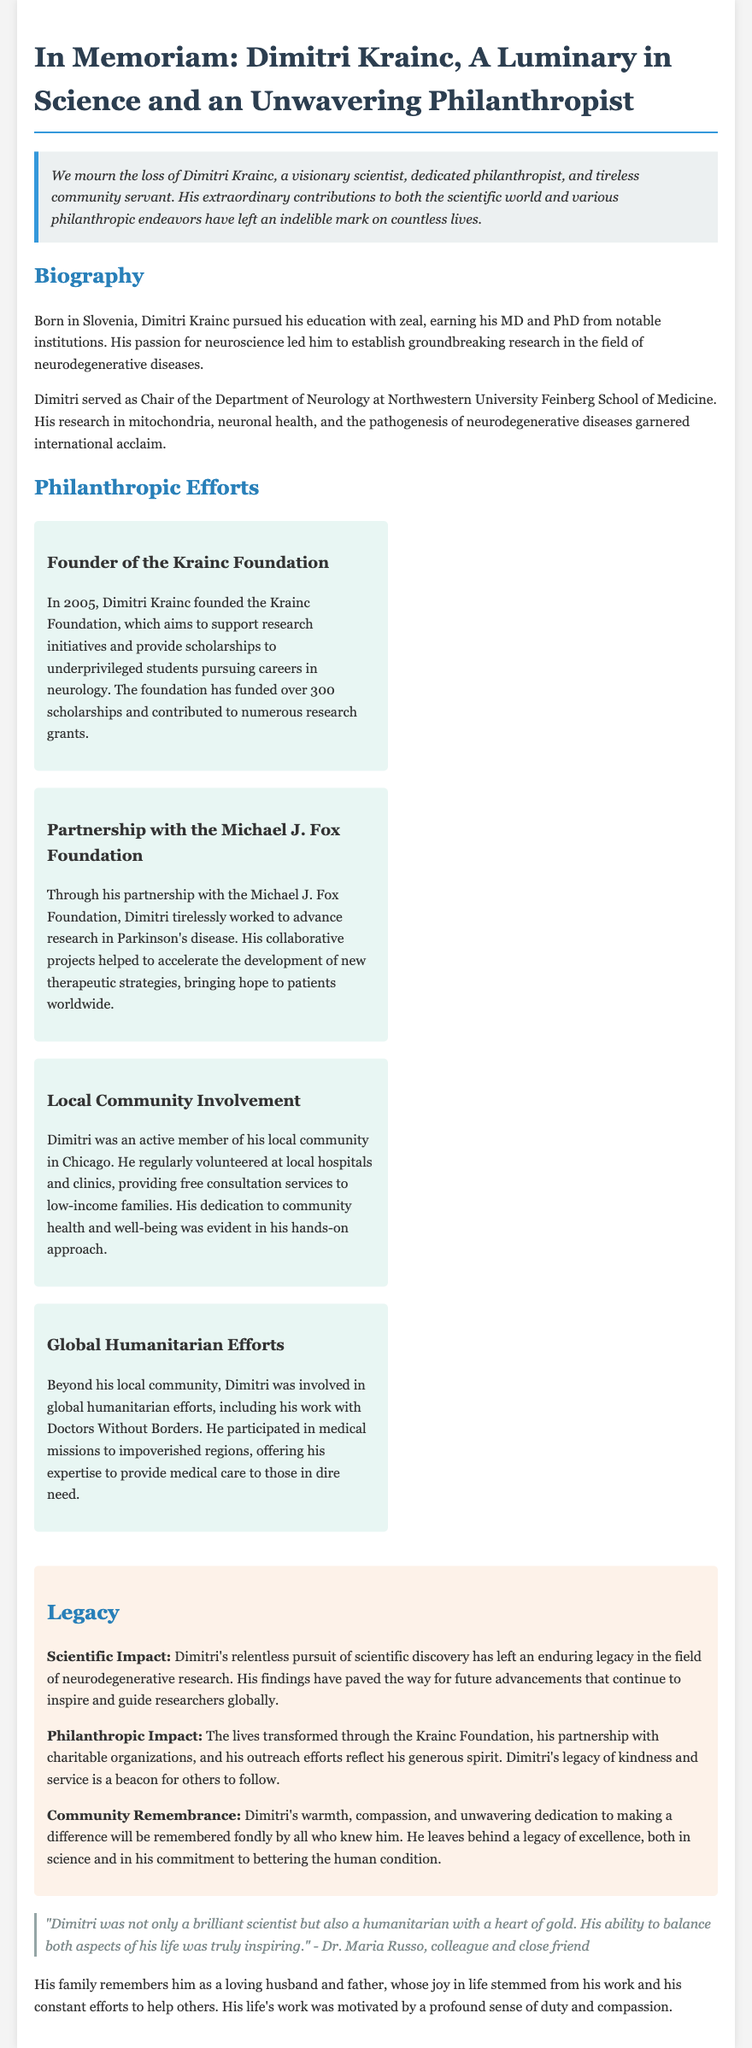What year was the Krainc Foundation founded? The document states that the Krainc Foundation was founded in 2005.
Answer: 2005 What type of diseases did Dimitri Krainc focus his research on? The document mentions that his research focused on neurodegenerative diseases.
Answer: Neurodegenerative diseases How many scholarships has the Krainc Foundation funded? The document indicates that the foundation has funded over 300 scholarships.
Answer: Over 300 scholarships What organization did Dimitri partner with to advance research in Parkinson's disease? The document specifies that he partnered with the Michael J. Fox Foundation.
Answer: Michael J. Fox Foundation What was one of the global humanitarian efforts Dimitri was involved in? The document describes his work with Doctors Without Borders as a global humanitarian effort.
Answer: Doctors Without Borders What aspect of Dimitri Krainc's work does the legacy section highlight? The legacy section highlights both his scientific impact and philanthropic impact.
Answer: Scientific impact and philanthropic impact Who is quoted in the document reflecting on Dimitri's character? The document includes a quote from Dr. Maria Russo, a colleague and close friend.
Answer: Dr. Maria Russo What geographic location was mentioned regarding Dimitri's community involvement? The document states that he was active in the local community in Chicago.
Answer: Chicago 